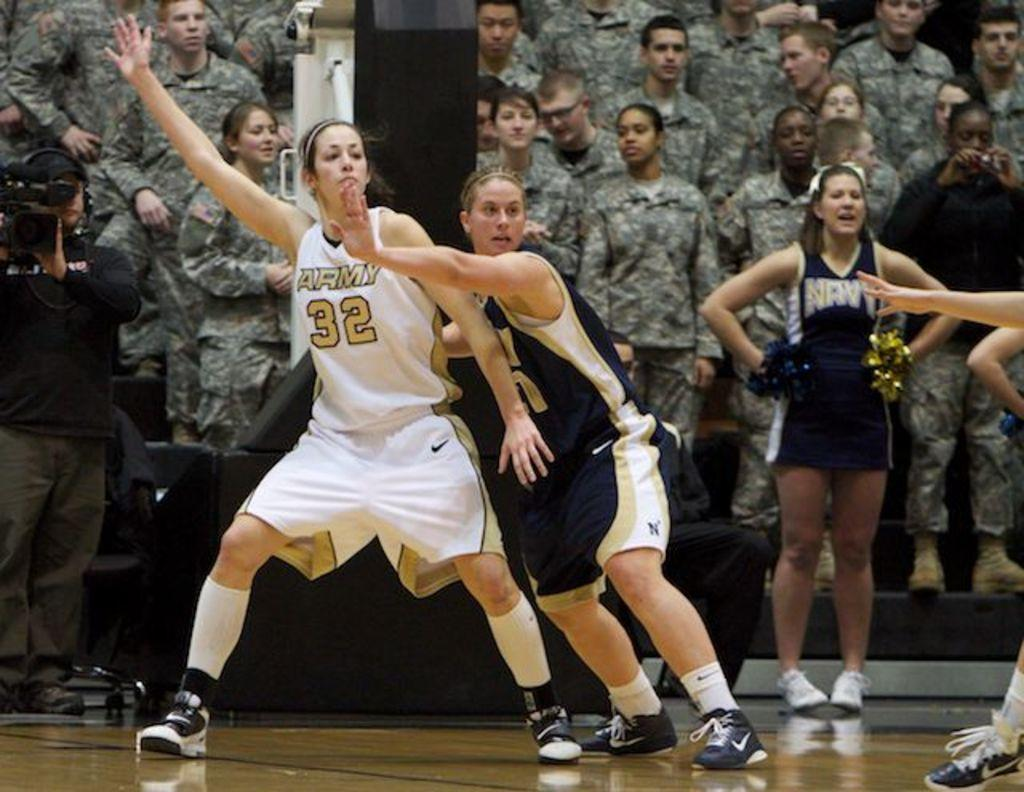<image>
Present a compact description of the photo's key features. Women playing basketball, one with 32 on her shirt, in front of an audience of soldiers. 